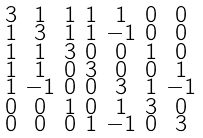<formula> <loc_0><loc_0><loc_500><loc_500>\begin{smallmatrix} 3 & 1 & 1 & 1 & 1 & 0 & 0 \\ 1 & 3 & 1 & 1 & - 1 & 0 & 0 \\ 1 & 1 & 3 & 0 & 0 & 1 & 0 \\ 1 & 1 & 0 & 3 & 0 & 0 & 1 \\ 1 & - 1 & 0 & 0 & 3 & 1 & - 1 \\ 0 & 0 & 1 & 0 & 1 & 3 & 0 \\ 0 & 0 & 0 & 1 & - 1 & 0 & 3 \end{smallmatrix}</formula> 